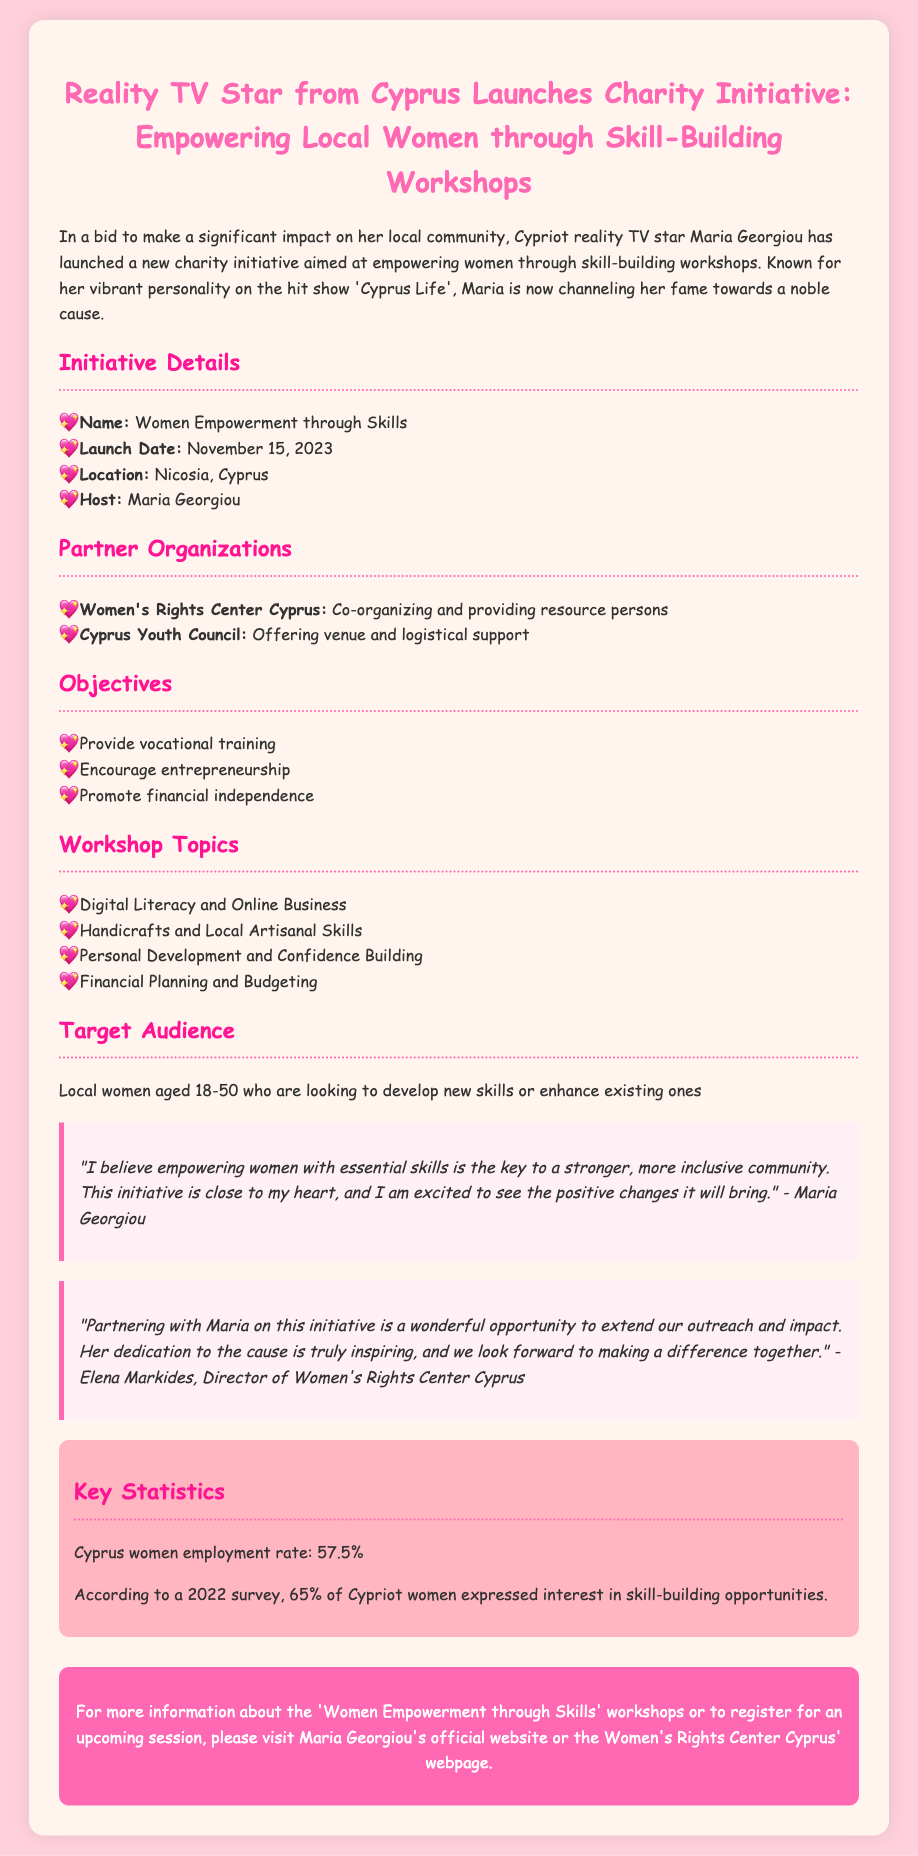What is the name of the initiative? The document states that the initiative is called "Women Empowerment through Skills."
Answer: Women Empowerment through Skills When is the launch date of the initiative? According to the document, the launch date is mentioned as November 15, 2023.
Answer: November 15, 2023 Where is the initiative taking place? The document specifies that the location of the initiative is Nicosia, Cyprus.
Answer: Nicosia, Cyprus Who is hosting the initiative? The document identifies Maria Georgiou as the host of the initiative.
Answer: Maria Georgiou What organization is co-organizing the initiative? The Women's Rights Center Cyprus is stated as the co-organizer in the document.
Answer: Women's Rights Center Cyprus What is one of the objectives of the workshops? The document lists several objectives, one of which is to promote financial independence.
Answer: Promote financial independence What age group is the target audience for the workshops? The target audience for the workshops is women aged 18-50, as stated in the document.
Answer: 18-50 According to the document, what percentage of Cypriot women expressed interest in skill-building opportunities? The document notes that 65% of Cypriot women expressed interest in skill-building opportunities according to a 2022 survey.
Answer: 65% Who expressed excitement about the initiative in a quote? Maria Georgiou expresses excitement about the initiative in her quote.
Answer: Maria Georgiou 